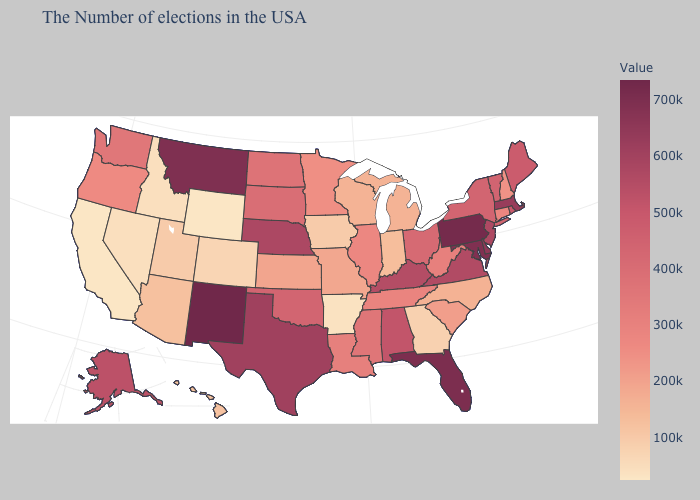Does the map have missing data?
Write a very short answer. No. Which states have the lowest value in the Northeast?
Concise answer only. New Hampshire. Among the states that border Alabama , which have the lowest value?
Give a very brief answer. Georgia. Which states have the lowest value in the USA?
Give a very brief answer. California. 